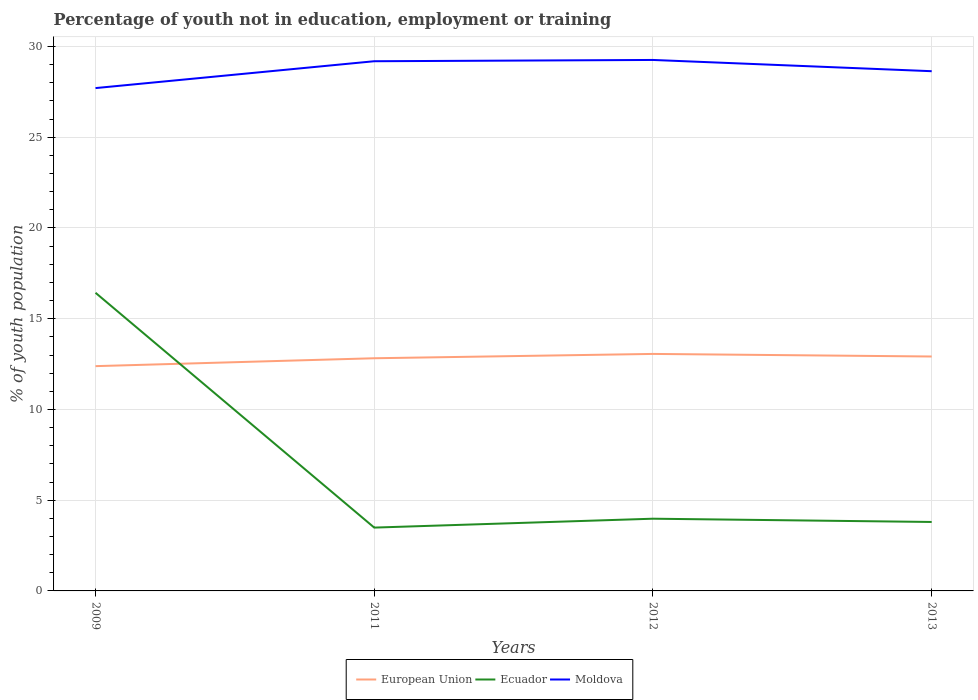How many different coloured lines are there?
Give a very brief answer. 3. Across all years, what is the maximum percentage of unemployed youth population in in Moldova?
Offer a terse response. 27.71. What is the total percentage of unemployed youth population in in European Union in the graph?
Make the answer very short. 0.14. What is the difference between the highest and the second highest percentage of unemployed youth population in in European Union?
Your answer should be very brief. 0.67. What is the difference between the highest and the lowest percentage of unemployed youth population in in European Union?
Offer a very short reply. 3. How many years are there in the graph?
Keep it short and to the point. 4. What is the difference between two consecutive major ticks on the Y-axis?
Your answer should be very brief. 5. Does the graph contain grids?
Offer a very short reply. Yes. Where does the legend appear in the graph?
Offer a terse response. Bottom center. How are the legend labels stacked?
Your response must be concise. Horizontal. What is the title of the graph?
Your response must be concise. Percentage of youth not in education, employment or training. Does "St. Kitts and Nevis" appear as one of the legend labels in the graph?
Ensure brevity in your answer.  No. What is the label or title of the Y-axis?
Give a very brief answer. % of youth population. What is the % of youth population of European Union in 2009?
Make the answer very short. 12.39. What is the % of youth population in Ecuador in 2009?
Offer a very short reply. 16.43. What is the % of youth population of Moldova in 2009?
Your response must be concise. 27.71. What is the % of youth population in European Union in 2011?
Make the answer very short. 12.82. What is the % of youth population in Ecuador in 2011?
Your response must be concise. 3.49. What is the % of youth population in Moldova in 2011?
Offer a very short reply. 29.19. What is the % of youth population of European Union in 2012?
Your response must be concise. 13.06. What is the % of youth population of Ecuador in 2012?
Your response must be concise. 3.98. What is the % of youth population in Moldova in 2012?
Make the answer very short. 29.26. What is the % of youth population of European Union in 2013?
Offer a terse response. 12.92. What is the % of youth population in Ecuador in 2013?
Your answer should be compact. 3.8. What is the % of youth population of Moldova in 2013?
Offer a terse response. 28.64. Across all years, what is the maximum % of youth population of European Union?
Your answer should be very brief. 13.06. Across all years, what is the maximum % of youth population in Ecuador?
Your answer should be very brief. 16.43. Across all years, what is the maximum % of youth population of Moldova?
Give a very brief answer. 29.26. Across all years, what is the minimum % of youth population of European Union?
Your response must be concise. 12.39. Across all years, what is the minimum % of youth population of Ecuador?
Make the answer very short. 3.49. Across all years, what is the minimum % of youth population in Moldova?
Ensure brevity in your answer.  27.71. What is the total % of youth population in European Union in the graph?
Make the answer very short. 51.19. What is the total % of youth population in Ecuador in the graph?
Provide a short and direct response. 27.7. What is the total % of youth population in Moldova in the graph?
Make the answer very short. 114.8. What is the difference between the % of youth population in European Union in 2009 and that in 2011?
Offer a very short reply. -0.43. What is the difference between the % of youth population of Ecuador in 2009 and that in 2011?
Ensure brevity in your answer.  12.94. What is the difference between the % of youth population in Moldova in 2009 and that in 2011?
Give a very brief answer. -1.48. What is the difference between the % of youth population of European Union in 2009 and that in 2012?
Your answer should be compact. -0.67. What is the difference between the % of youth population of Ecuador in 2009 and that in 2012?
Ensure brevity in your answer.  12.45. What is the difference between the % of youth population of Moldova in 2009 and that in 2012?
Your answer should be very brief. -1.55. What is the difference between the % of youth population in European Union in 2009 and that in 2013?
Offer a terse response. -0.53. What is the difference between the % of youth population in Ecuador in 2009 and that in 2013?
Make the answer very short. 12.63. What is the difference between the % of youth population in Moldova in 2009 and that in 2013?
Ensure brevity in your answer.  -0.93. What is the difference between the % of youth population in European Union in 2011 and that in 2012?
Ensure brevity in your answer.  -0.24. What is the difference between the % of youth population in Ecuador in 2011 and that in 2012?
Your answer should be very brief. -0.49. What is the difference between the % of youth population of Moldova in 2011 and that in 2012?
Your answer should be compact. -0.07. What is the difference between the % of youth population in European Union in 2011 and that in 2013?
Your answer should be compact. -0.1. What is the difference between the % of youth population of Ecuador in 2011 and that in 2013?
Offer a terse response. -0.31. What is the difference between the % of youth population in Moldova in 2011 and that in 2013?
Your answer should be compact. 0.55. What is the difference between the % of youth population of European Union in 2012 and that in 2013?
Keep it short and to the point. 0.14. What is the difference between the % of youth population of Ecuador in 2012 and that in 2013?
Offer a very short reply. 0.18. What is the difference between the % of youth population in Moldova in 2012 and that in 2013?
Make the answer very short. 0.62. What is the difference between the % of youth population of European Union in 2009 and the % of youth population of Ecuador in 2011?
Provide a short and direct response. 8.9. What is the difference between the % of youth population in European Union in 2009 and the % of youth population in Moldova in 2011?
Offer a very short reply. -16.8. What is the difference between the % of youth population of Ecuador in 2009 and the % of youth population of Moldova in 2011?
Ensure brevity in your answer.  -12.76. What is the difference between the % of youth population of European Union in 2009 and the % of youth population of Ecuador in 2012?
Keep it short and to the point. 8.41. What is the difference between the % of youth population in European Union in 2009 and the % of youth population in Moldova in 2012?
Give a very brief answer. -16.87. What is the difference between the % of youth population of Ecuador in 2009 and the % of youth population of Moldova in 2012?
Provide a succinct answer. -12.83. What is the difference between the % of youth population in European Union in 2009 and the % of youth population in Ecuador in 2013?
Your response must be concise. 8.59. What is the difference between the % of youth population in European Union in 2009 and the % of youth population in Moldova in 2013?
Provide a short and direct response. -16.25. What is the difference between the % of youth population in Ecuador in 2009 and the % of youth population in Moldova in 2013?
Ensure brevity in your answer.  -12.21. What is the difference between the % of youth population of European Union in 2011 and the % of youth population of Ecuador in 2012?
Your response must be concise. 8.84. What is the difference between the % of youth population of European Union in 2011 and the % of youth population of Moldova in 2012?
Your response must be concise. -16.44. What is the difference between the % of youth population of Ecuador in 2011 and the % of youth population of Moldova in 2012?
Ensure brevity in your answer.  -25.77. What is the difference between the % of youth population in European Union in 2011 and the % of youth population in Ecuador in 2013?
Provide a short and direct response. 9.02. What is the difference between the % of youth population in European Union in 2011 and the % of youth population in Moldova in 2013?
Offer a terse response. -15.82. What is the difference between the % of youth population in Ecuador in 2011 and the % of youth population in Moldova in 2013?
Provide a short and direct response. -25.15. What is the difference between the % of youth population of European Union in 2012 and the % of youth population of Ecuador in 2013?
Your answer should be very brief. 9.26. What is the difference between the % of youth population in European Union in 2012 and the % of youth population in Moldova in 2013?
Offer a very short reply. -15.58. What is the difference between the % of youth population in Ecuador in 2012 and the % of youth population in Moldova in 2013?
Keep it short and to the point. -24.66. What is the average % of youth population of European Union per year?
Provide a succinct answer. 12.8. What is the average % of youth population in Ecuador per year?
Offer a very short reply. 6.92. What is the average % of youth population in Moldova per year?
Keep it short and to the point. 28.7. In the year 2009, what is the difference between the % of youth population of European Union and % of youth population of Ecuador?
Offer a terse response. -4.04. In the year 2009, what is the difference between the % of youth population in European Union and % of youth population in Moldova?
Provide a succinct answer. -15.32. In the year 2009, what is the difference between the % of youth population in Ecuador and % of youth population in Moldova?
Your response must be concise. -11.28. In the year 2011, what is the difference between the % of youth population in European Union and % of youth population in Ecuador?
Your answer should be very brief. 9.33. In the year 2011, what is the difference between the % of youth population of European Union and % of youth population of Moldova?
Give a very brief answer. -16.37. In the year 2011, what is the difference between the % of youth population of Ecuador and % of youth population of Moldova?
Give a very brief answer. -25.7. In the year 2012, what is the difference between the % of youth population in European Union and % of youth population in Ecuador?
Offer a terse response. 9.08. In the year 2012, what is the difference between the % of youth population in European Union and % of youth population in Moldova?
Your answer should be very brief. -16.2. In the year 2012, what is the difference between the % of youth population of Ecuador and % of youth population of Moldova?
Your answer should be compact. -25.28. In the year 2013, what is the difference between the % of youth population in European Union and % of youth population in Ecuador?
Ensure brevity in your answer.  9.12. In the year 2013, what is the difference between the % of youth population of European Union and % of youth population of Moldova?
Keep it short and to the point. -15.72. In the year 2013, what is the difference between the % of youth population of Ecuador and % of youth population of Moldova?
Ensure brevity in your answer.  -24.84. What is the ratio of the % of youth population in European Union in 2009 to that in 2011?
Your answer should be compact. 0.97. What is the ratio of the % of youth population of Ecuador in 2009 to that in 2011?
Give a very brief answer. 4.71. What is the ratio of the % of youth population of Moldova in 2009 to that in 2011?
Ensure brevity in your answer.  0.95. What is the ratio of the % of youth population of European Union in 2009 to that in 2012?
Provide a short and direct response. 0.95. What is the ratio of the % of youth population of Ecuador in 2009 to that in 2012?
Provide a succinct answer. 4.13. What is the ratio of the % of youth population of Moldova in 2009 to that in 2012?
Your answer should be very brief. 0.95. What is the ratio of the % of youth population in European Union in 2009 to that in 2013?
Your answer should be very brief. 0.96. What is the ratio of the % of youth population of Ecuador in 2009 to that in 2013?
Give a very brief answer. 4.32. What is the ratio of the % of youth population in Moldova in 2009 to that in 2013?
Offer a very short reply. 0.97. What is the ratio of the % of youth population in European Union in 2011 to that in 2012?
Give a very brief answer. 0.98. What is the ratio of the % of youth population of Ecuador in 2011 to that in 2012?
Provide a short and direct response. 0.88. What is the ratio of the % of youth population in Ecuador in 2011 to that in 2013?
Make the answer very short. 0.92. What is the ratio of the % of youth population in Moldova in 2011 to that in 2013?
Your response must be concise. 1.02. What is the ratio of the % of youth population of Ecuador in 2012 to that in 2013?
Provide a succinct answer. 1.05. What is the ratio of the % of youth population in Moldova in 2012 to that in 2013?
Make the answer very short. 1.02. What is the difference between the highest and the second highest % of youth population in European Union?
Provide a succinct answer. 0.14. What is the difference between the highest and the second highest % of youth population in Ecuador?
Make the answer very short. 12.45. What is the difference between the highest and the second highest % of youth population of Moldova?
Provide a short and direct response. 0.07. What is the difference between the highest and the lowest % of youth population of European Union?
Provide a succinct answer. 0.67. What is the difference between the highest and the lowest % of youth population of Ecuador?
Offer a very short reply. 12.94. What is the difference between the highest and the lowest % of youth population in Moldova?
Offer a very short reply. 1.55. 